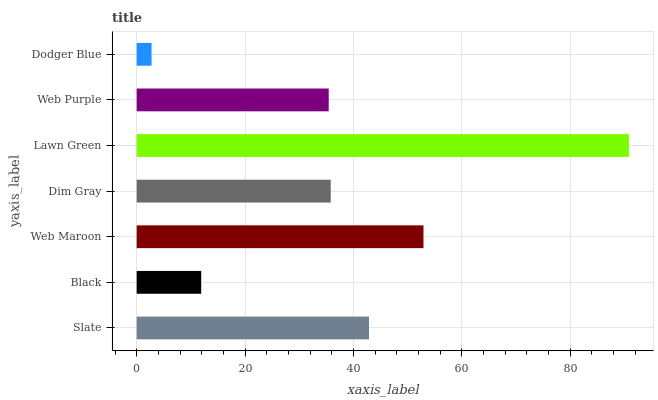Is Dodger Blue the minimum?
Answer yes or no. Yes. Is Lawn Green the maximum?
Answer yes or no. Yes. Is Black the minimum?
Answer yes or no. No. Is Black the maximum?
Answer yes or no. No. Is Slate greater than Black?
Answer yes or no. Yes. Is Black less than Slate?
Answer yes or no. Yes. Is Black greater than Slate?
Answer yes or no. No. Is Slate less than Black?
Answer yes or no. No. Is Dim Gray the high median?
Answer yes or no. Yes. Is Dim Gray the low median?
Answer yes or no. Yes. Is Slate the high median?
Answer yes or no. No. Is Black the low median?
Answer yes or no. No. 